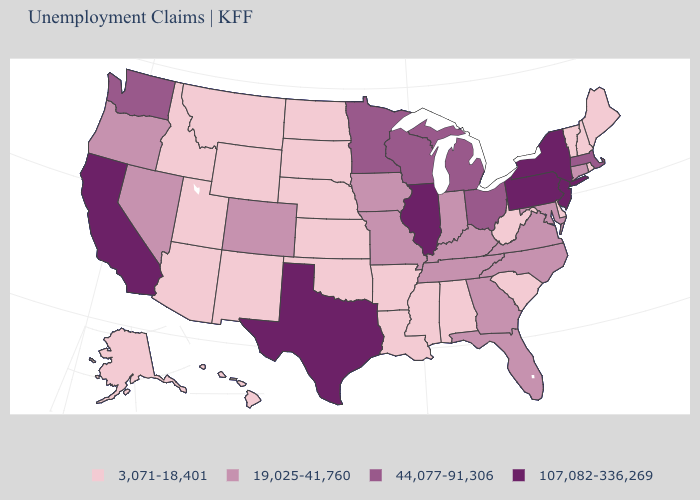Which states have the highest value in the USA?
Write a very short answer. California, Illinois, New Jersey, New York, Pennsylvania, Texas. Name the states that have a value in the range 44,077-91,306?
Quick response, please. Massachusetts, Michigan, Minnesota, Ohio, Washington, Wisconsin. Among the states that border Nevada , which have the highest value?
Answer briefly. California. What is the value of Iowa?
Concise answer only. 19,025-41,760. What is the value of California?
Be succinct. 107,082-336,269. What is the value of Rhode Island?
Be succinct. 3,071-18,401. Among the states that border Vermont , does New Hampshire have the lowest value?
Short answer required. Yes. What is the value of Michigan?
Write a very short answer. 44,077-91,306. Among the states that border Utah , which have the highest value?
Give a very brief answer. Colorado, Nevada. Which states hav the highest value in the South?
Keep it brief. Texas. Name the states that have a value in the range 19,025-41,760?
Short answer required. Colorado, Connecticut, Florida, Georgia, Indiana, Iowa, Kentucky, Maryland, Missouri, Nevada, North Carolina, Oregon, Tennessee, Virginia. What is the value of Georgia?
Be succinct. 19,025-41,760. Name the states that have a value in the range 44,077-91,306?
Quick response, please. Massachusetts, Michigan, Minnesota, Ohio, Washington, Wisconsin. What is the highest value in states that border Idaho?
Give a very brief answer. 44,077-91,306. Which states have the highest value in the USA?
Be succinct. California, Illinois, New Jersey, New York, Pennsylvania, Texas. 